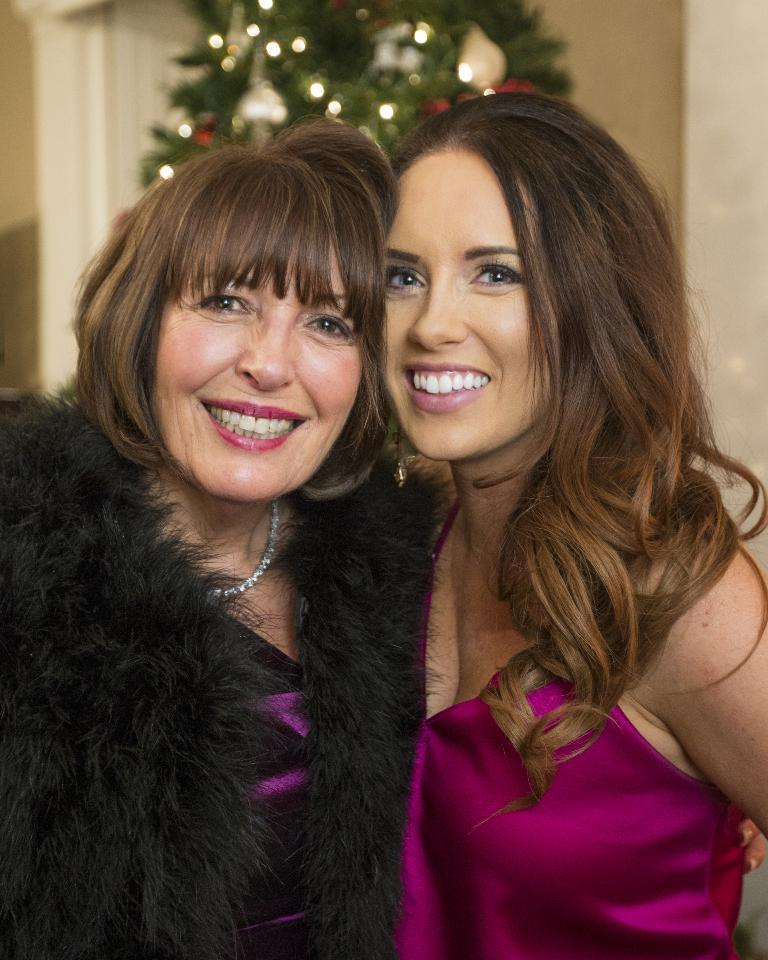How many people are in the image? There are two persons in the image. What is the background of the image? The two persons are in front of a Christmas tree. What are the persons wearing? Both persons are wearing clothes. Can you see any wounds on the persons in the image? There is no indication of any wounds on the persons in the image. What type of joke is being told by the persons in the image? There is no indication of any jokes being told in the image; the focus is on the two persons and the Christmas tree. 